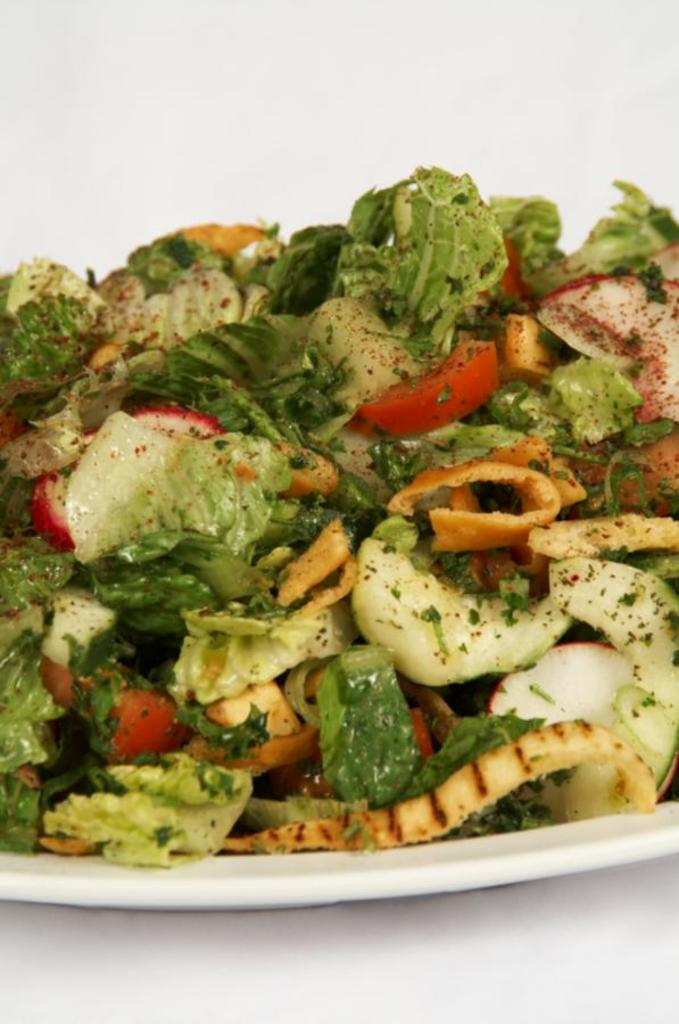What is on the white plate in the image? There is food on a white plate in the image. What can be seen at the bottom of the image? The bottom of the image shows a surface. What color is present at the top of the image? The top of the image has a white color. What type of pest can be seen crawling on the food in the image? There is no pest present in the image; the food appears to be undisturbed. 